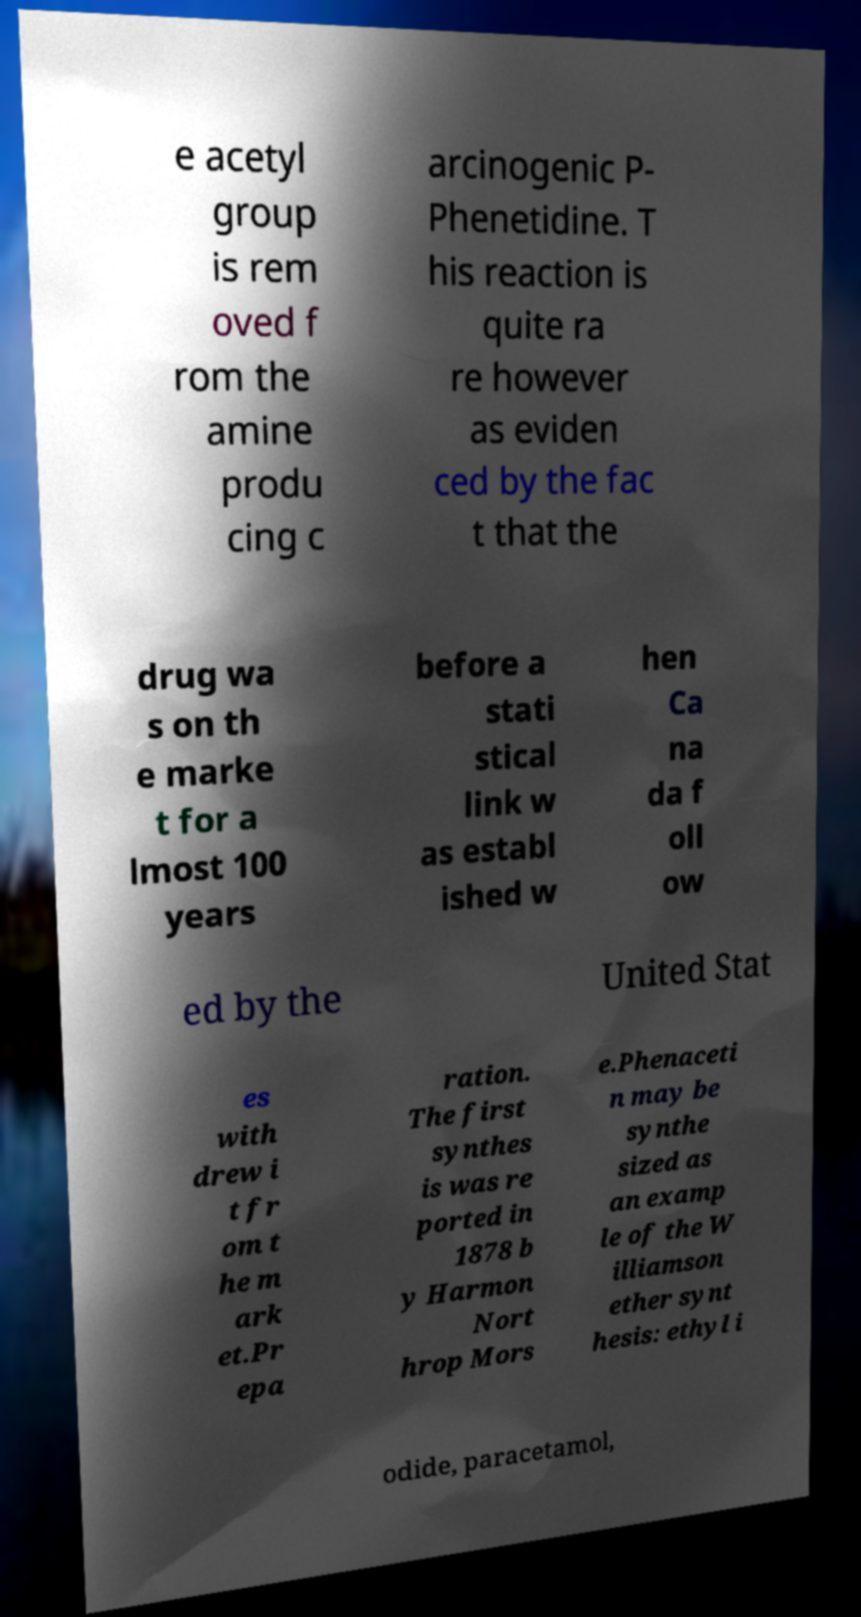There's text embedded in this image that I need extracted. Can you transcribe it verbatim? e acetyl group is rem oved f rom the amine produ cing c arcinogenic P- Phenetidine. T his reaction is quite ra re however as eviden ced by the fac t that the drug wa s on th e marke t for a lmost 100 years before a stati stical link w as establ ished w hen Ca na da f oll ow ed by the United Stat es with drew i t fr om t he m ark et.Pr epa ration. The first synthes is was re ported in 1878 b y Harmon Nort hrop Mors e.Phenaceti n may be synthe sized as an examp le of the W illiamson ether synt hesis: ethyl i odide, paracetamol, 